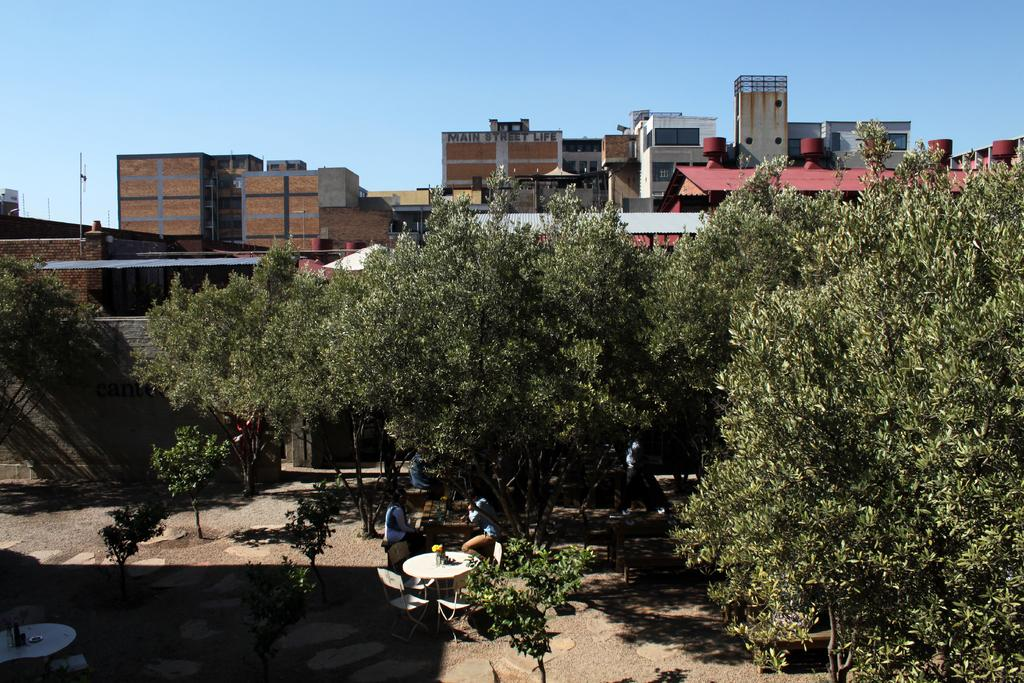What type of furniture can be seen in the front of the image? There are chairs in the front of the image. Who or what is in front of the image? There are people in the front of the image. What other objects are in the front of the image besides chairs? There are tables and trees in the front of the image. Can you describe the objects in the front of the image? There are objects in the front of the image, but the specific details are not provided in the facts. What can be seen in the background of the image? There are buildings, poles, and the sky visible in the background of the image. What type of story is being told by the arm in the image? There is no arm present in the image, and therefore no story can be told by it. What type of paper is visible in the image? There is no paper visible in the image. 